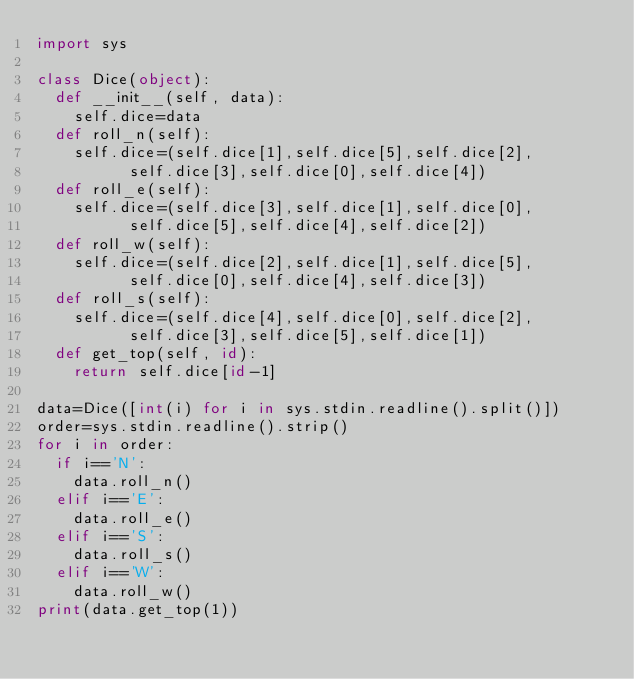Convert code to text. <code><loc_0><loc_0><loc_500><loc_500><_Python_>import sys

class Dice(object):
	def __init__(self, data):
		self.dice=data
	def roll_n(self):
		self.dice=(self.dice[1],self.dice[5],self.dice[2],
					self.dice[3],self.dice[0],self.dice[4])
	def roll_e(self):
		self.dice=(self.dice[3],self.dice[1],self.dice[0],
					self.dice[5],self.dice[4],self.dice[2])
	def roll_w(self):
		self.dice=(self.dice[2],self.dice[1],self.dice[5],
					self.dice[0],self.dice[4],self.dice[3])				
	def roll_s(self):
		self.dice=(self.dice[4],self.dice[0],self.dice[2],
					self.dice[3],self.dice[5],self.dice[1])
	def get_top(self, id):
 		return self.dice[id-1]

data=Dice([int(i) for i in sys.stdin.readline().split()])
order=sys.stdin.readline().strip()
for i in order:
	if i=='N':
		data.roll_n()
	elif i=='E':
		data.roll_e()
	elif i=='S':
		data.roll_s()
	elif i=='W':
		data.roll_w()
print(data.get_top(1))</code> 